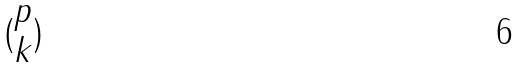<formula> <loc_0><loc_0><loc_500><loc_500>( \begin{matrix} p \\ k \end{matrix} )</formula> 